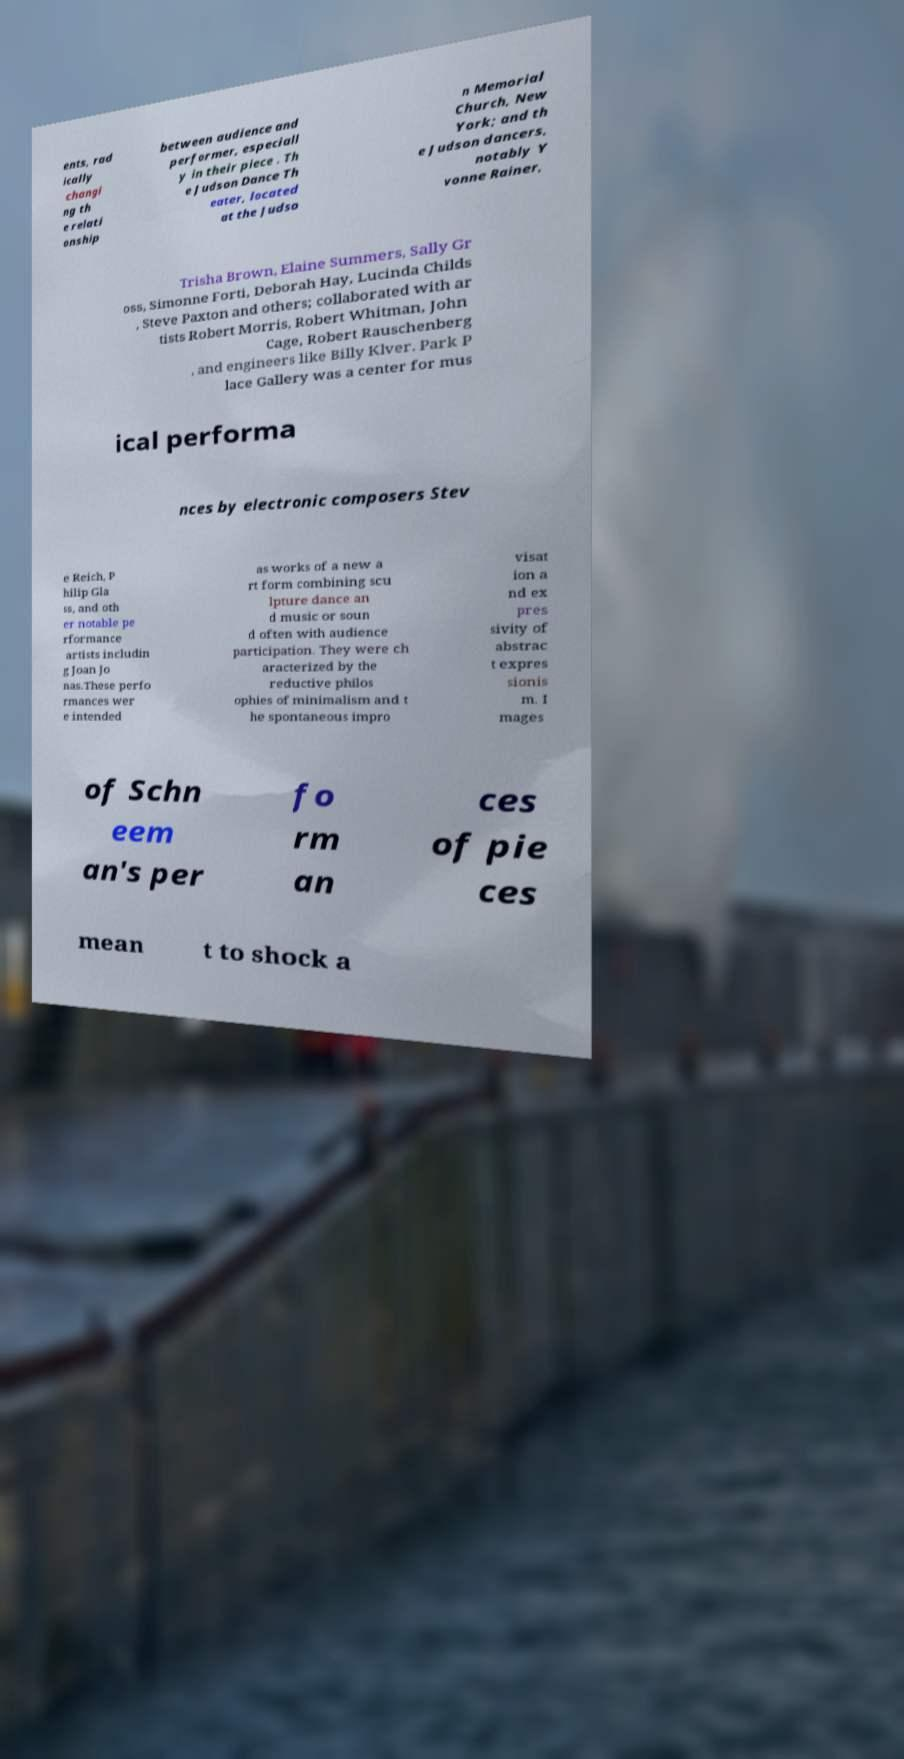There's text embedded in this image that I need extracted. Can you transcribe it verbatim? ents, rad ically changi ng th e relati onship between audience and performer, especiall y in their piece . Th e Judson Dance Th eater, located at the Judso n Memorial Church, New York; and th e Judson dancers, notably Y vonne Rainer, Trisha Brown, Elaine Summers, Sally Gr oss, Simonne Forti, Deborah Hay, Lucinda Childs , Steve Paxton and others; collaborated with ar tists Robert Morris, Robert Whitman, John Cage, Robert Rauschenberg , and engineers like Billy Klver. Park P lace Gallery was a center for mus ical performa nces by electronic composers Stev e Reich, P hilip Gla ss, and oth er notable pe rformance artists includin g Joan Jo nas.These perfo rmances wer e intended as works of a new a rt form combining scu lpture dance an d music or soun d often with audience participation. They were ch aracterized by the reductive philos ophies of minimalism and t he spontaneous impro visat ion a nd ex pres sivity of abstrac t expres sionis m. I mages of Schn eem an's per fo rm an ces of pie ces mean t to shock a 